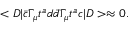<formula> <loc_0><loc_0><loc_500><loc_500>< D | \bar { c } \Gamma _ { \mu } t ^ { a } d \bar { d } \Gamma _ { \mu } t ^ { a } c | D > \approx 0 .</formula> 